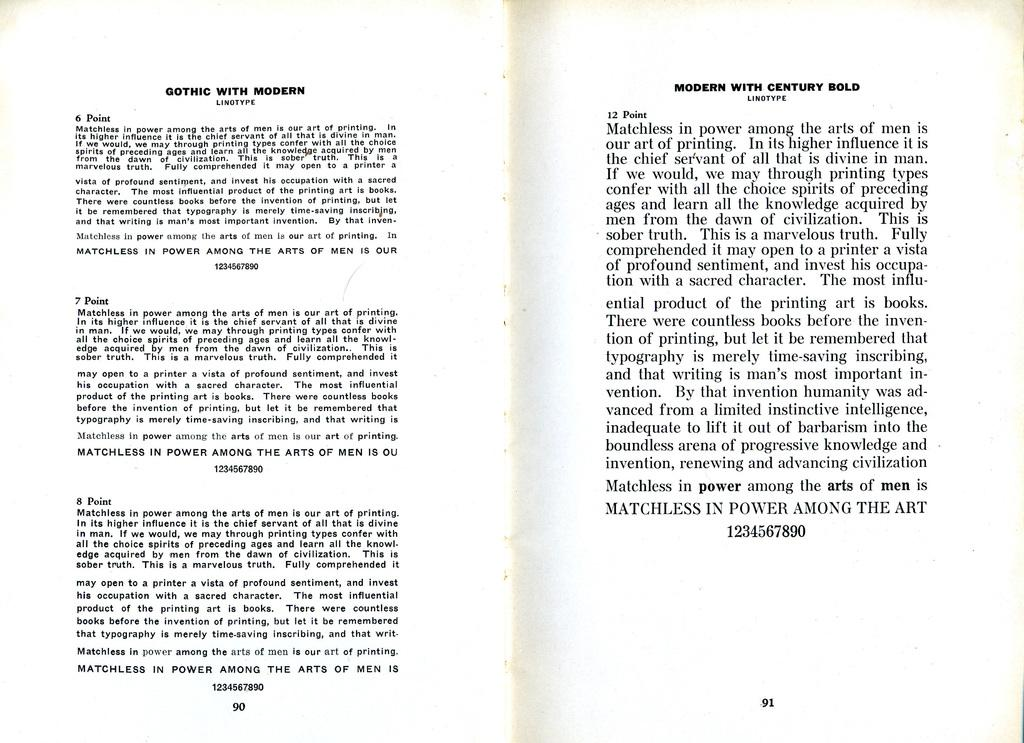<image>
Write a terse but informative summary of the picture. A book is opened to a page that discusses Gothic with Modern. 